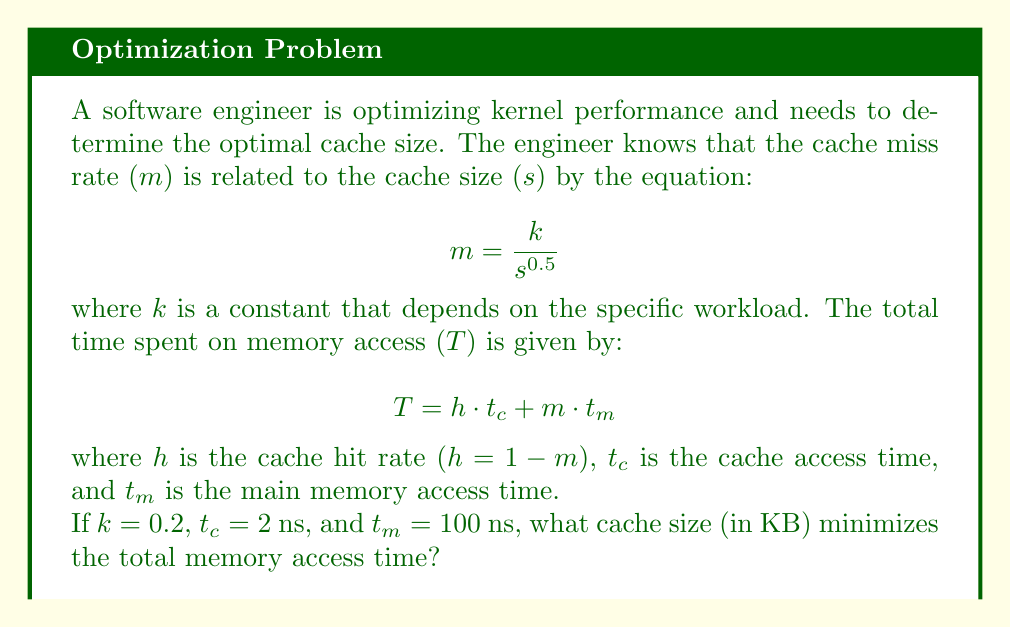Could you help me with this problem? To solve this problem, we need to follow these steps:

1) First, let's express $h$ in terms of $s$:
   $h = 1 - m = 1 - \frac{k}{s^{0.5}} = 1 - \frac{0.2}{s^{0.5}}$

2) Now, we can rewrite the total time function:
   $$T = (1 - \frac{0.2}{s^{0.5}}) \cdot 2 + \frac{0.2}{s^{0.5}} \cdot 100$$

3) Simplify:
   $$T = 2 - \frac{0.4}{s^{0.5}} + \frac{20}{s^{0.5}} = 2 + \frac{19.6}{s^{0.5}}$$

4) To find the minimum, we need to differentiate $T$ with respect to $s$ and set it to zero:
   $$\frac{dT}{ds} = -\frac{19.6}{2} \cdot s^{-1.5} = 0$$

5) Solving this equation:
   $$-\frac{19.6}{2} \cdot s^{-1.5} = 0$$
   $$s^{-1.5} = 0$$
   $$s = \infty$$

6) This result suggests that theoretically, the larger the cache, the better. However, in practice, we need to consider other constraints like cost and diminishing returns.

7) Let's say we want to find the cache size where the total time is within 1% of the asymptotic minimum (which is 2 ns):
   $$2 + \frac{19.6}{s^{0.5}} = 2.02$$

8) Solving for $s$:
   $$\frac{19.6}{s^{0.5}} = 0.02$$
   $$s^{0.5} = \frac{19.6}{0.02} = 980$$
   $$s = 980^2 = 960,400$$

9) Convert to KB:
   $$960,400 \text{ bytes} = 937.89 \text{ KB} \approx 938 \text{ KB}$$
Answer: The optimal cache size is approximately 938 KB. 